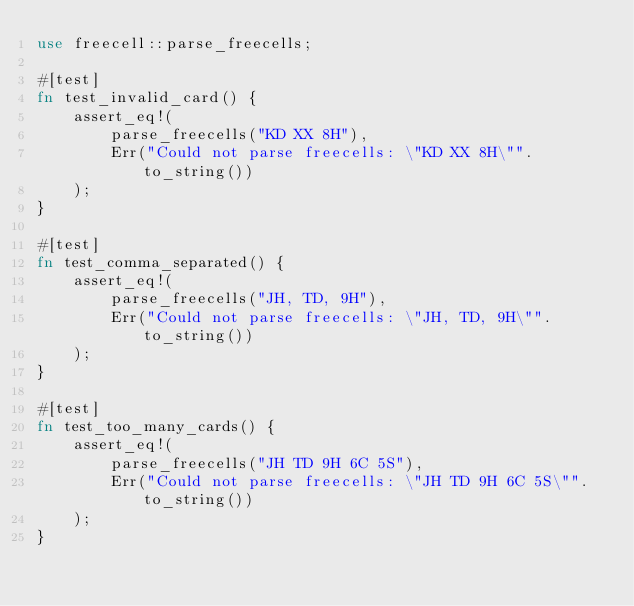<code> <loc_0><loc_0><loc_500><loc_500><_Rust_>use freecell::parse_freecells;

#[test]
fn test_invalid_card() {
    assert_eq!(
        parse_freecells("KD XX 8H"),
        Err("Could not parse freecells: \"KD XX 8H\"".to_string())
    );
}

#[test]
fn test_comma_separated() {
    assert_eq!(
        parse_freecells("JH, TD, 9H"),
        Err("Could not parse freecells: \"JH, TD, 9H\"".to_string())
    );
}

#[test]
fn test_too_many_cards() {
    assert_eq!(
        parse_freecells("JH TD 9H 6C 5S"),
        Err("Could not parse freecells: \"JH TD 9H 6C 5S\"".to_string())
    );
}
</code> 